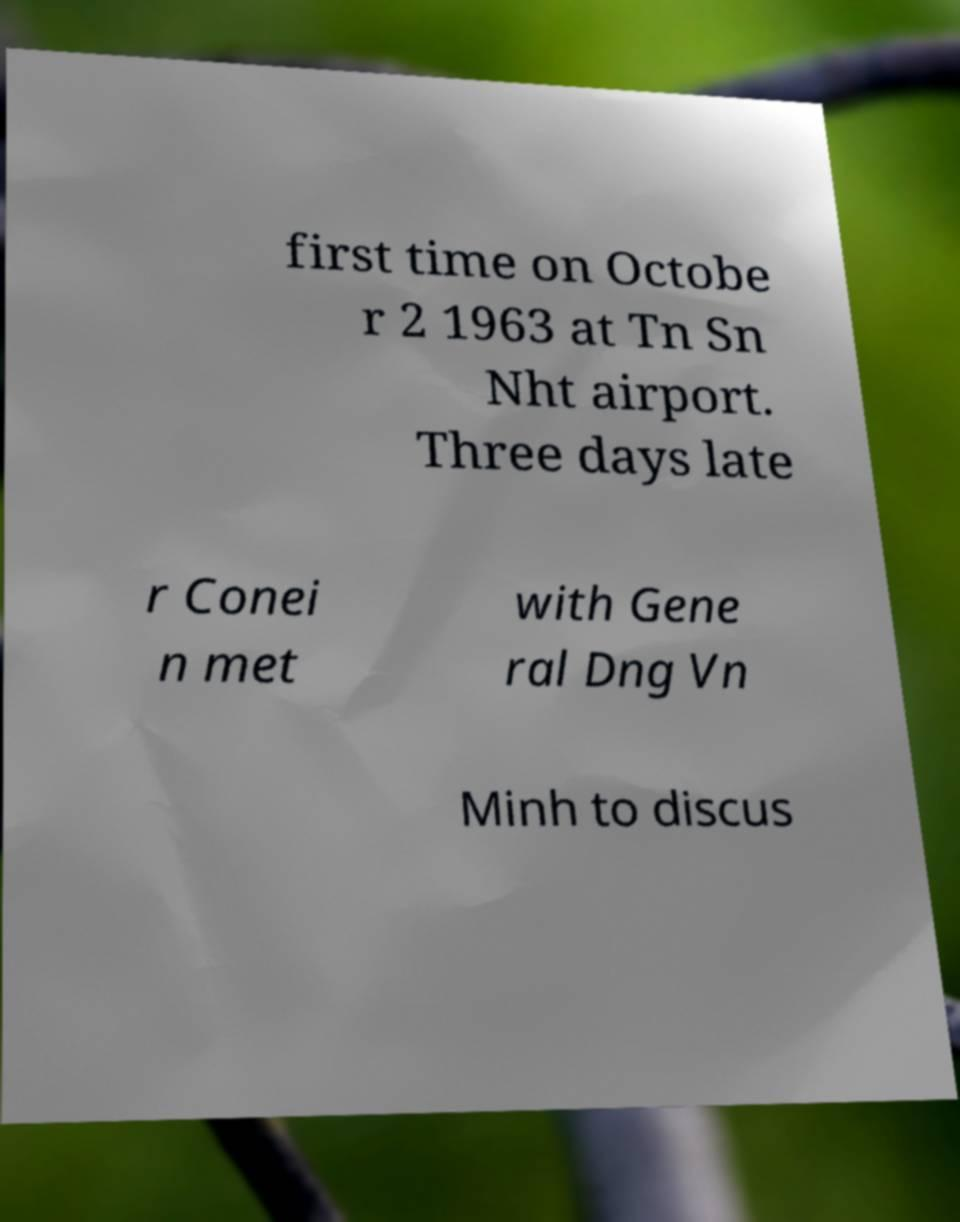For documentation purposes, I need the text within this image transcribed. Could you provide that? first time on Octobe r 2 1963 at Tn Sn Nht airport. Three days late r Conei n met with Gene ral Dng Vn Minh to discus 